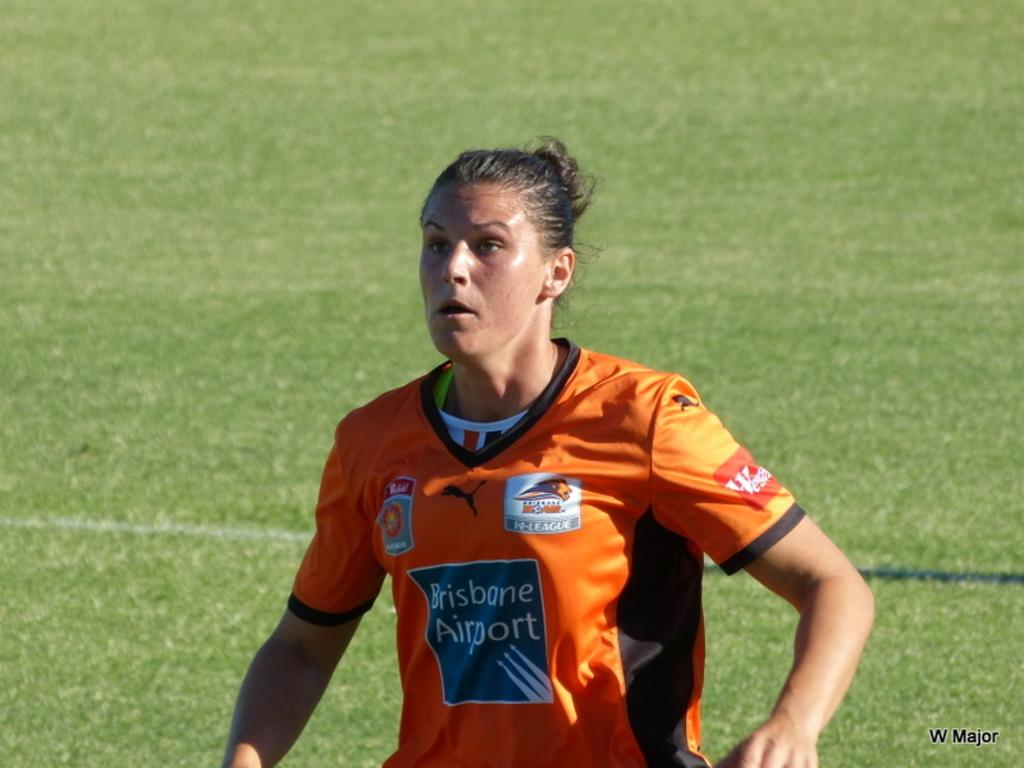<image>
Present a compact description of the photo's key features. A girl wearing an orange shirt with Brisbane Airport on it. 